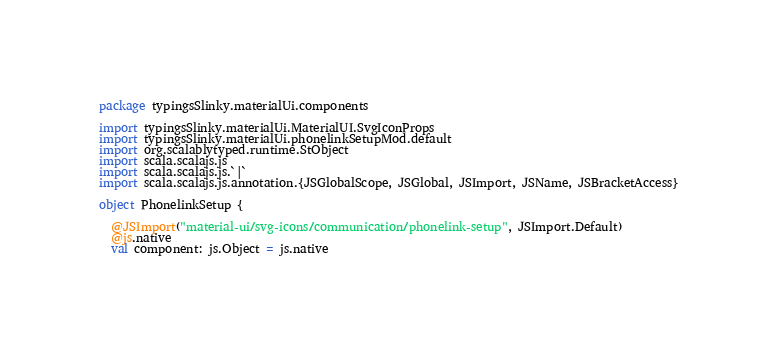Convert code to text. <code><loc_0><loc_0><loc_500><loc_500><_Scala_>package typingsSlinky.materialUi.components

import typingsSlinky.materialUi.MaterialUI.SvgIconProps
import typingsSlinky.materialUi.phonelinkSetupMod.default
import org.scalablytyped.runtime.StObject
import scala.scalajs.js
import scala.scalajs.js.`|`
import scala.scalajs.js.annotation.{JSGlobalScope, JSGlobal, JSImport, JSName, JSBracketAccess}

object PhonelinkSetup {
  
  @JSImport("material-ui/svg-icons/communication/phonelink-setup", JSImport.Default)
  @js.native
  val component: js.Object = js.native
  </code> 